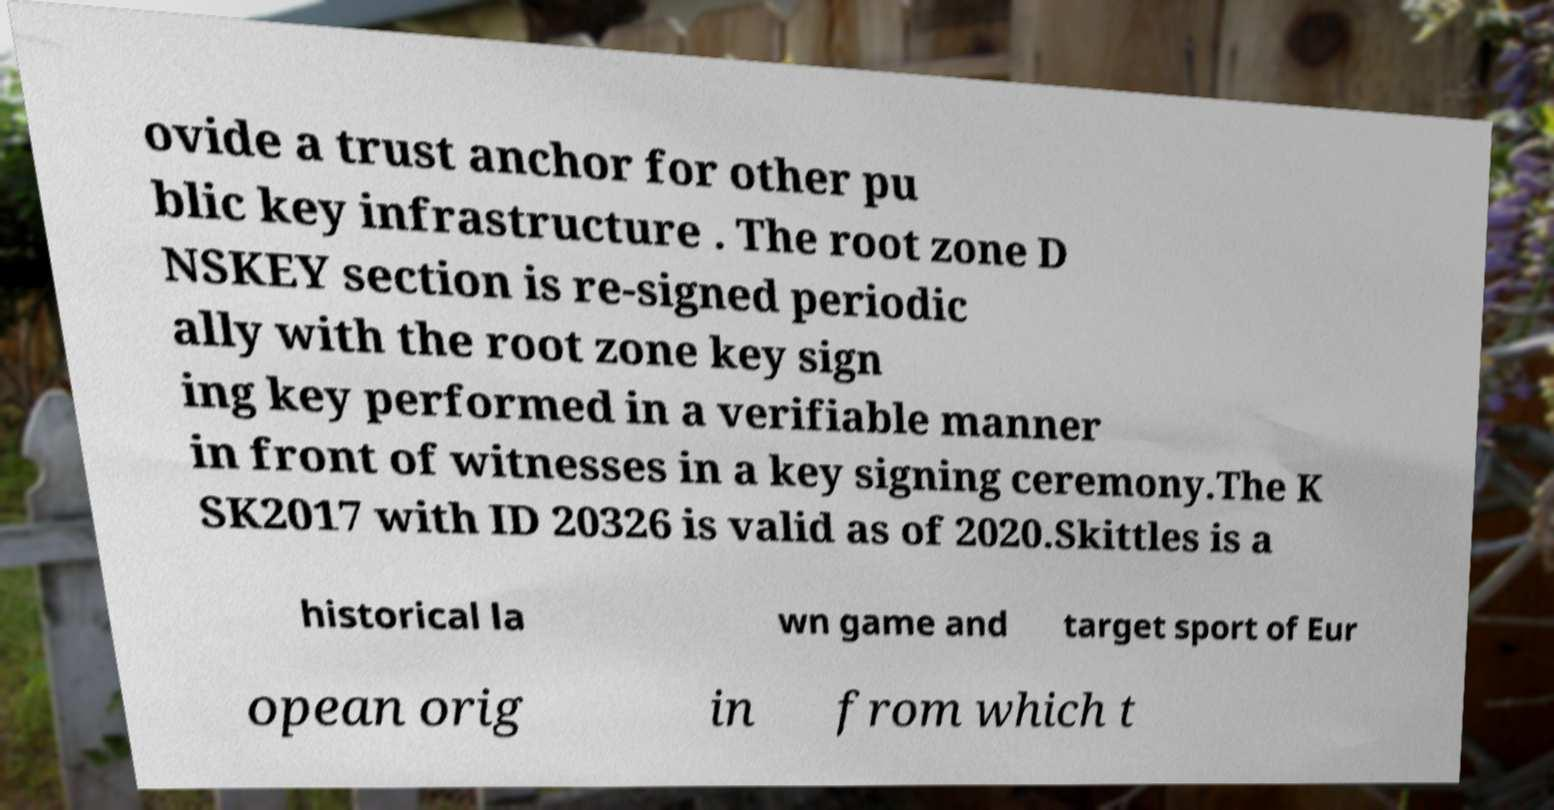Can you accurately transcribe the text from the provided image for me? ovide a trust anchor for other pu blic key infrastructure . The root zone D NSKEY section is re-signed periodic ally with the root zone key sign ing key performed in a verifiable manner in front of witnesses in a key signing ceremony.The K SK2017 with ID 20326 is valid as of 2020.Skittles is a historical la wn game and target sport of Eur opean orig in from which t 